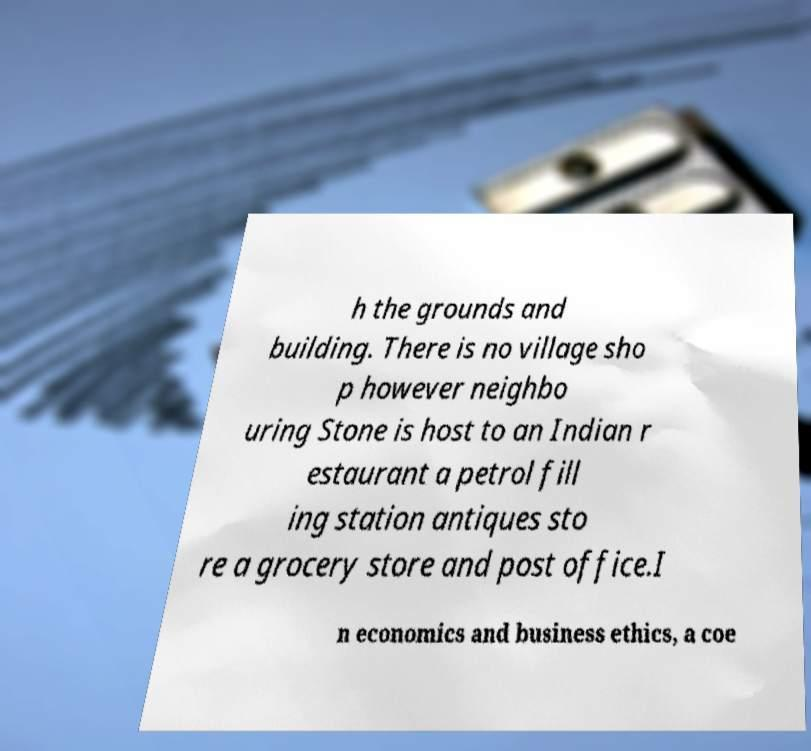For documentation purposes, I need the text within this image transcribed. Could you provide that? h the grounds and building. There is no village sho p however neighbo uring Stone is host to an Indian r estaurant a petrol fill ing station antiques sto re a grocery store and post office.I n economics and business ethics, a coe 